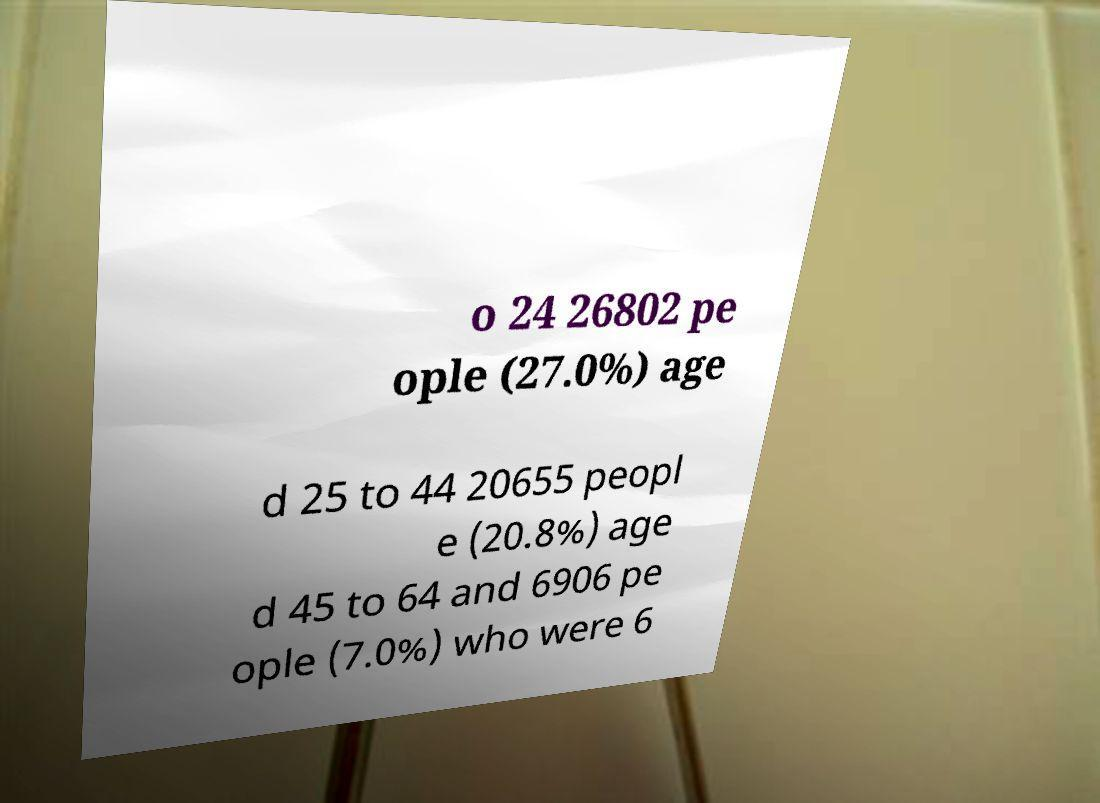Please identify and transcribe the text found in this image. o 24 26802 pe ople (27.0%) age d 25 to 44 20655 peopl e (20.8%) age d 45 to 64 and 6906 pe ople (7.0%) who were 6 